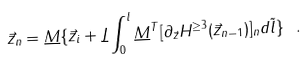Convert formula to latex. <formula><loc_0><loc_0><loc_500><loc_500>\vec { z } _ { n } = \underline { M } \{ \vec { z } _ { i } + \underline { J } \int _ { 0 } ^ { l } { \underline { M } } ^ { T } [ \partial _ { \vec { z } } H ^ { \geq 3 } ( \vec { z } _ { n - 1 } ) ] _ { n } d \tilde { l } \} \ .</formula> 